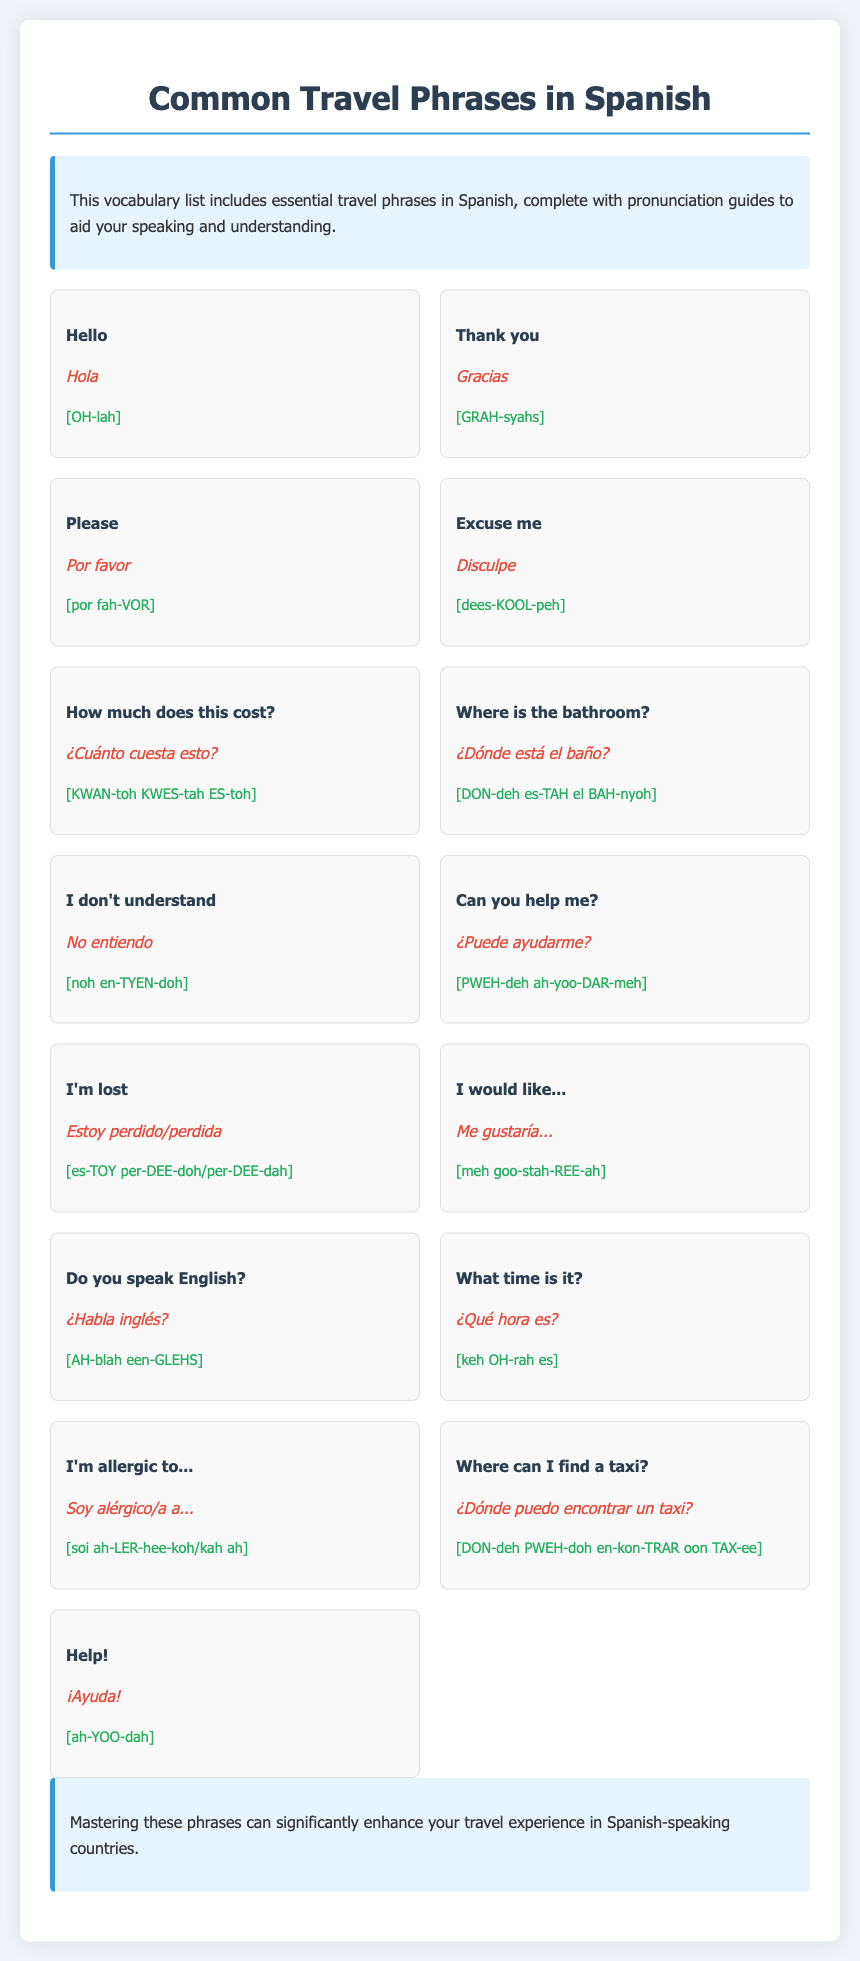What is the Spanish word for "Hello"? The document lists essential travel phrases, and "Hello" in Spanish is indicated as "Hola."
Answer: Hola How do you say "Thank you" in Spanish? "Thank you" is translated to "Gracias" in the vocabulary list provided.
Answer: Gracias What is the pronunciation of "Excuse me"? The pronunciation of "Excuse me" as noted in the document is given as [dees-KOOL-peh].
Answer: [dees-KOOL-peh] What question would you ask to find out the price of something? The phrase to ask about the cost is "How much does this cost?" translated to Spanish as "¿Cuánto cuesta esto?"
Answer: ¿Cuánto cuesta esto? How do you express that you don't understand? The phrase "I don't understand" is translated to "No entiendo" in Spanish.
Answer: No entiendo What is the Spanish phrase for asking for help? The phrase "Help!" is expressed in Spanish as "¡Ayuda!" in the vocabulary list.
Answer: ¡Ayuda! What would you say if you are lost? If you are lost, you would say "I'm lost," which translates to "Estoy perdido/perdida" in Spanish.
Answer: Estoy perdido/perdida What is the purpose of this document? The document aims to provide essential travel phrases in Spanish, along with pronunciation guides.
Answer: Essential travel phrases What does the introduction highlight about the vocabulary list? The introduction emphasizes that the vocabulary list includes essential phrases with pronunciation guides to aid speaking.
Answer: Essential phrases with pronunciation guides 